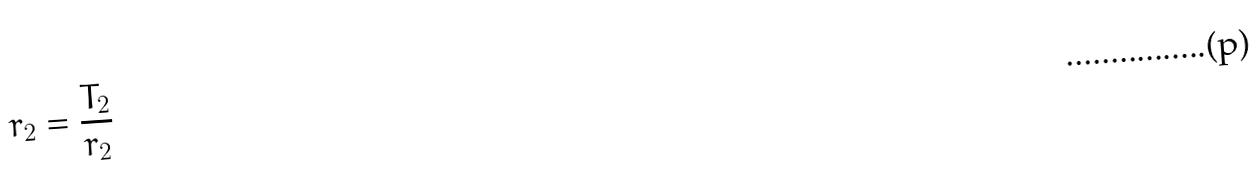Convert formula to latex. <formula><loc_0><loc_0><loc_500><loc_500>r _ { 2 } = \frac { T _ { 2 } } { r _ { 2 } }</formula> 